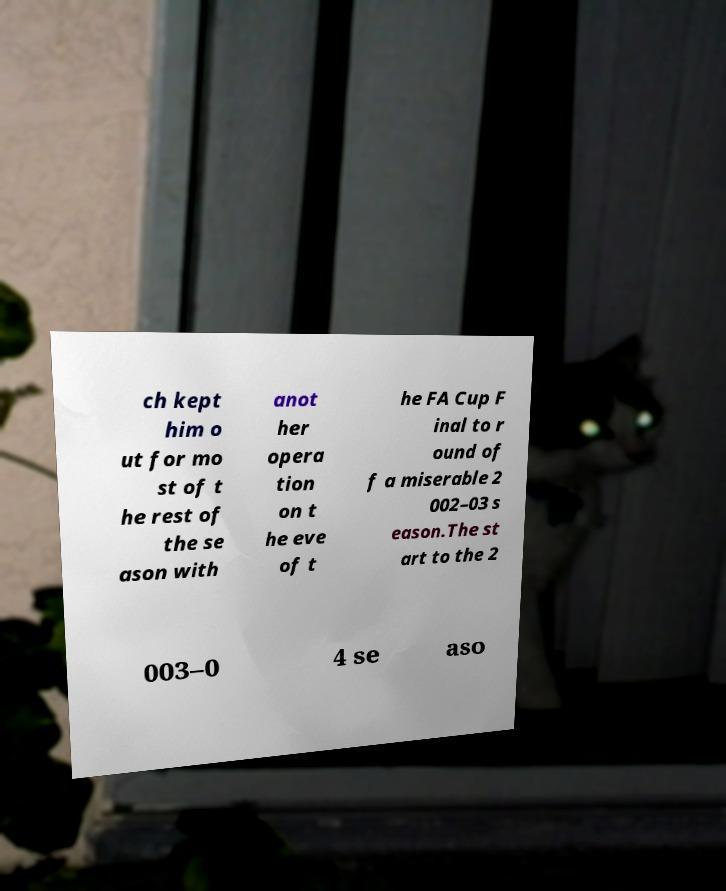There's text embedded in this image that I need extracted. Can you transcribe it verbatim? ch kept him o ut for mo st of t he rest of the se ason with anot her opera tion on t he eve of t he FA Cup F inal to r ound of f a miserable 2 002–03 s eason.The st art to the 2 003–0 4 se aso 